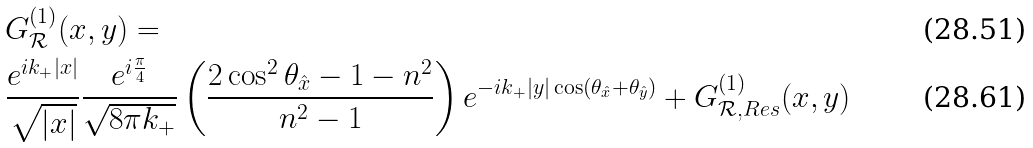<formula> <loc_0><loc_0><loc_500><loc_500>& G ^ { ( 1 ) } _ { \mathcal { R } } ( x , y ) = \\ & \frac { e ^ { i k _ { + } | x | } } { \sqrt { | x | } } \frac { e ^ { i \frac { \pi } 4 } } { \sqrt { 8 \pi k _ { + } } } \left ( \frac { 2 \cos ^ { 2 } \theta _ { \hat { x } } - 1 - n ^ { 2 } } { n ^ { 2 } - 1 } \right ) e ^ { - i k _ { + } | y | \cos ( \theta _ { \hat { x } } { + } \theta _ { \hat { y } } ) } + G ^ { ( 1 ) } _ { \mathcal { R } , R e s } ( x , y )</formula> 